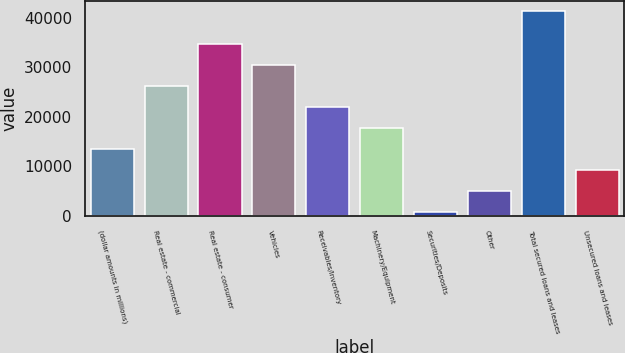<chart> <loc_0><loc_0><loc_500><loc_500><bar_chart><fcel>(dollar amounts in millions)<fcel>Real estate - commercial<fcel>Real estate - consumer<fcel>Vehicles<fcel>Receivables/Inventory<fcel>Machinery/Equipment<fcel>Securities/Deposits<fcel>Other<fcel>Total secured loans and leases<fcel>Unsecured loans and leases<nl><fcel>13486.2<fcel>26186.4<fcel>34653.2<fcel>30419.8<fcel>21953<fcel>17719.6<fcel>786<fcel>5019.4<fcel>41342<fcel>9252.8<nl></chart> 